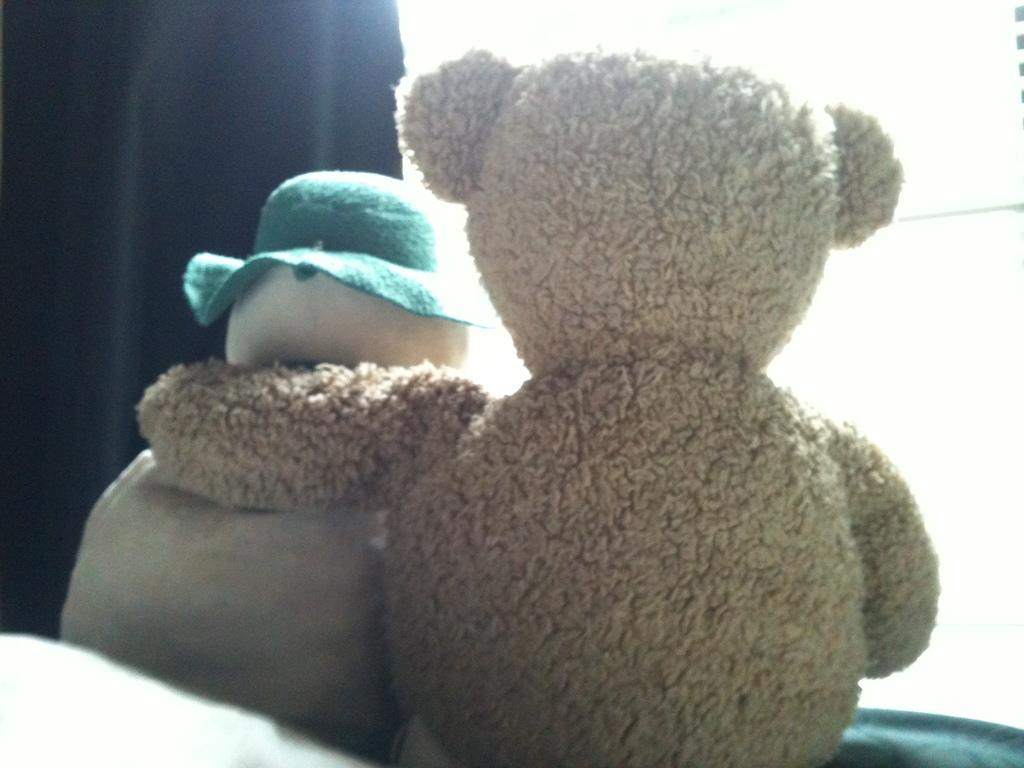How many dolls are present in the image? There are two dolls in the image. What colors can be seen on the dolls? The dolls are in cream, white, and green colors. What is visible in the background of the image? There is a curtain in the background of the image. How does the doll roll on the floor in the image? There is no indication that the dolls are rolling on the floor in the image. 